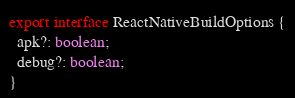<code> <loc_0><loc_0><loc_500><loc_500><_TypeScript_>export interface ReactNativeBuildOptions {
  apk?: boolean;
  debug?: boolean;
}
</code> 